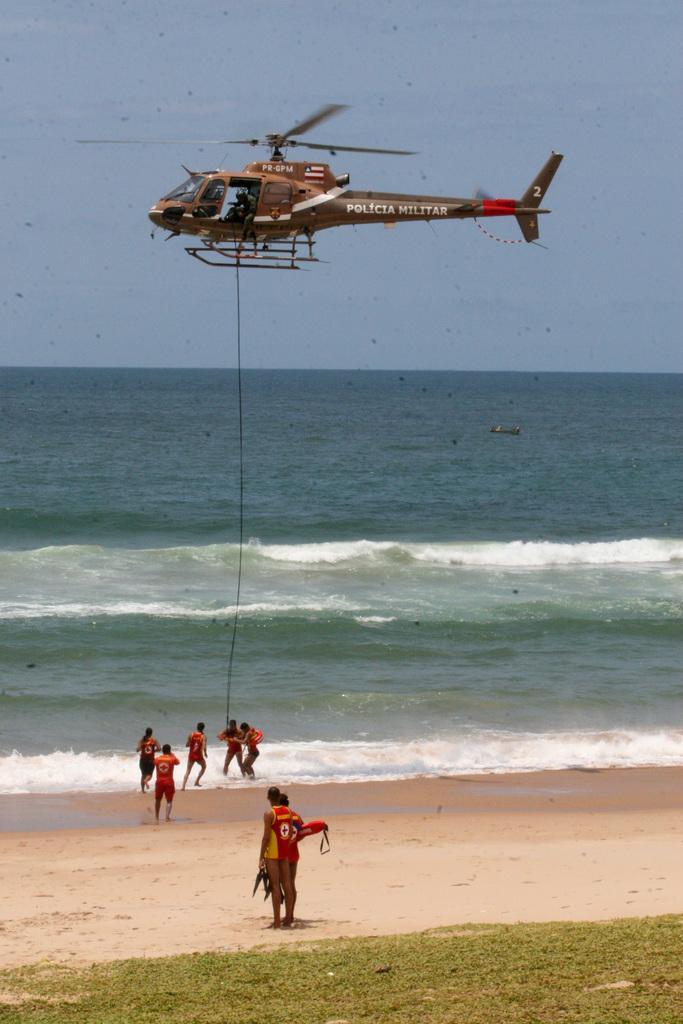How would you summarize this image in a sentence or two? There is grass on the ground. Beside this grass, there is a person in red color t-shirt, holding an object and standing on a sand surface. In the background, there are persons near tides of the ocean. Beside them, there is a thread from an aircraft which is in the air. In the background, there is blue sky. 